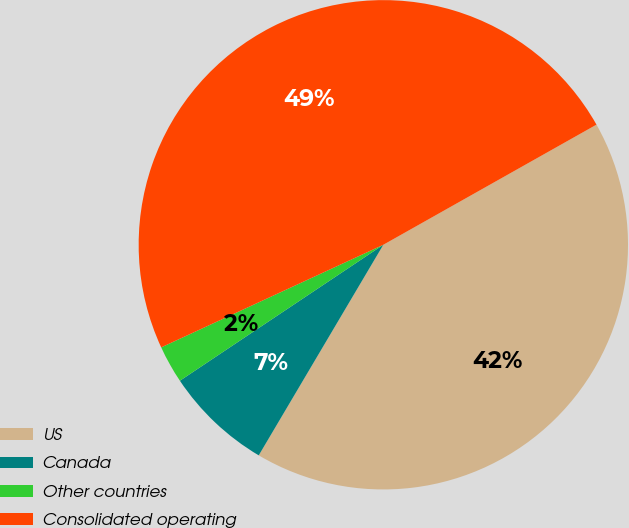Convert chart. <chart><loc_0><loc_0><loc_500><loc_500><pie_chart><fcel>US<fcel>Canada<fcel>Other countries<fcel>Consolidated operating<nl><fcel>41.67%<fcel>7.12%<fcel>2.49%<fcel>48.72%<nl></chart> 